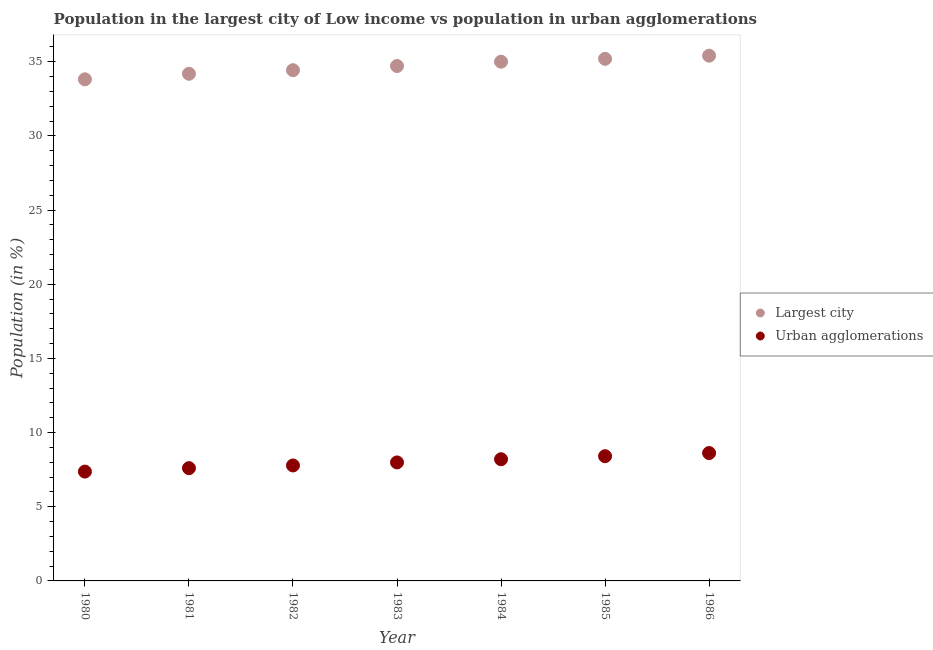How many different coloured dotlines are there?
Offer a terse response. 2. Is the number of dotlines equal to the number of legend labels?
Offer a very short reply. Yes. What is the population in urban agglomerations in 1985?
Ensure brevity in your answer.  8.41. Across all years, what is the maximum population in urban agglomerations?
Keep it short and to the point. 8.62. Across all years, what is the minimum population in urban agglomerations?
Keep it short and to the point. 7.37. In which year was the population in urban agglomerations minimum?
Make the answer very short. 1980. What is the total population in the largest city in the graph?
Ensure brevity in your answer.  242.8. What is the difference between the population in urban agglomerations in 1982 and that in 1985?
Offer a very short reply. -0.62. What is the difference between the population in urban agglomerations in 1982 and the population in the largest city in 1980?
Make the answer very short. -26.04. What is the average population in the largest city per year?
Give a very brief answer. 34.69. In the year 1985, what is the difference between the population in urban agglomerations and population in the largest city?
Your response must be concise. -26.79. What is the ratio of the population in the largest city in 1984 to that in 1986?
Your answer should be compact. 0.99. Is the population in urban agglomerations in 1983 less than that in 1984?
Your answer should be compact. Yes. Is the difference between the population in urban agglomerations in 1982 and 1983 greater than the difference between the population in the largest city in 1982 and 1983?
Make the answer very short. Yes. What is the difference between the highest and the second highest population in urban agglomerations?
Ensure brevity in your answer.  0.21. What is the difference between the highest and the lowest population in the largest city?
Make the answer very short. 1.59. Is the sum of the population in urban agglomerations in 1982 and 1984 greater than the maximum population in the largest city across all years?
Your answer should be very brief. No. Is the population in the largest city strictly less than the population in urban agglomerations over the years?
Your response must be concise. No. What is the difference between two consecutive major ticks on the Y-axis?
Your answer should be very brief. 5. Are the values on the major ticks of Y-axis written in scientific E-notation?
Offer a very short reply. No. Where does the legend appear in the graph?
Provide a short and direct response. Center right. What is the title of the graph?
Keep it short and to the point. Population in the largest city of Low income vs population in urban agglomerations. Does "Register a property" appear as one of the legend labels in the graph?
Make the answer very short. No. What is the label or title of the X-axis?
Offer a terse response. Year. What is the label or title of the Y-axis?
Offer a terse response. Population (in %). What is the Population (in %) in Largest city in 1980?
Offer a terse response. 33.82. What is the Population (in %) of Urban agglomerations in 1980?
Make the answer very short. 7.37. What is the Population (in %) of Largest city in 1981?
Offer a very short reply. 34.2. What is the Population (in %) of Urban agglomerations in 1981?
Your answer should be compact. 7.6. What is the Population (in %) in Largest city in 1982?
Offer a terse response. 34.44. What is the Population (in %) in Urban agglomerations in 1982?
Your answer should be compact. 7.78. What is the Population (in %) in Largest city in 1983?
Make the answer very short. 34.72. What is the Population (in %) of Urban agglomerations in 1983?
Make the answer very short. 7.99. What is the Population (in %) of Largest city in 1984?
Make the answer very short. 35.01. What is the Population (in %) in Urban agglomerations in 1984?
Make the answer very short. 8.2. What is the Population (in %) of Largest city in 1985?
Provide a short and direct response. 35.2. What is the Population (in %) in Urban agglomerations in 1985?
Keep it short and to the point. 8.41. What is the Population (in %) of Largest city in 1986?
Provide a short and direct response. 35.42. What is the Population (in %) of Urban agglomerations in 1986?
Your response must be concise. 8.62. Across all years, what is the maximum Population (in %) in Largest city?
Provide a short and direct response. 35.42. Across all years, what is the maximum Population (in %) in Urban agglomerations?
Your answer should be very brief. 8.62. Across all years, what is the minimum Population (in %) of Largest city?
Offer a terse response. 33.82. Across all years, what is the minimum Population (in %) in Urban agglomerations?
Keep it short and to the point. 7.37. What is the total Population (in %) in Largest city in the graph?
Ensure brevity in your answer.  242.8. What is the total Population (in %) of Urban agglomerations in the graph?
Provide a short and direct response. 55.99. What is the difference between the Population (in %) of Largest city in 1980 and that in 1981?
Give a very brief answer. -0.38. What is the difference between the Population (in %) of Urban agglomerations in 1980 and that in 1981?
Give a very brief answer. -0.23. What is the difference between the Population (in %) in Largest city in 1980 and that in 1982?
Provide a short and direct response. -0.62. What is the difference between the Population (in %) in Urban agglomerations in 1980 and that in 1982?
Your answer should be very brief. -0.41. What is the difference between the Population (in %) of Largest city in 1980 and that in 1983?
Ensure brevity in your answer.  -0.9. What is the difference between the Population (in %) of Urban agglomerations in 1980 and that in 1983?
Keep it short and to the point. -0.62. What is the difference between the Population (in %) of Largest city in 1980 and that in 1984?
Your response must be concise. -1.19. What is the difference between the Population (in %) of Urban agglomerations in 1980 and that in 1984?
Your answer should be very brief. -0.83. What is the difference between the Population (in %) of Largest city in 1980 and that in 1985?
Your answer should be compact. -1.38. What is the difference between the Population (in %) in Urban agglomerations in 1980 and that in 1985?
Provide a succinct answer. -1.04. What is the difference between the Population (in %) of Largest city in 1980 and that in 1986?
Offer a terse response. -1.59. What is the difference between the Population (in %) in Urban agglomerations in 1980 and that in 1986?
Give a very brief answer. -1.25. What is the difference between the Population (in %) in Largest city in 1981 and that in 1982?
Provide a short and direct response. -0.24. What is the difference between the Population (in %) in Urban agglomerations in 1981 and that in 1982?
Ensure brevity in your answer.  -0.18. What is the difference between the Population (in %) in Largest city in 1981 and that in 1983?
Offer a terse response. -0.52. What is the difference between the Population (in %) of Urban agglomerations in 1981 and that in 1983?
Ensure brevity in your answer.  -0.39. What is the difference between the Population (in %) in Largest city in 1981 and that in 1984?
Ensure brevity in your answer.  -0.81. What is the difference between the Population (in %) in Urban agglomerations in 1981 and that in 1984?
Offer a very short reply. -0.6. What is the difference between the Population (in %) in Largest city in 1981 and that in 1985?
Ensure brevity in your answer.  -1.01. What is the difference between the Population (in %) of Urban agglomerations in 1981 and that in 1985?
Provide a succinct answer. -0.81. What is the difference between the Population (in %) in Largest city in 1981 and that in 1986?
Provide a short and direct response. -1.22. What is the difference between the Population (in %) of Urban agglomerations in 1981 and that in 1986?
Provide a succinct answer. -1.02. What is the difference between the Population (in %) of Largest city in 1982 and that in 1983?
Give a very brief answer. -0.28. What is the difference between the Population (in %) of Urban agglomerations in 1982 and that in 1983?
Provide a succinct answer. -0.2. What is the difference between the Population (in %) of Largest city in 1982 and that in 1984?
Provide a succinct answer. -0.57. What is the difference between the Population (in %) of Urban agglomerations in 1982 and that in 1984?
Give a very brief answer. -0.42. What is the difference between the Population (in %) of Largest city in 1982 and that in 1985?
Keep it short and to the point. -0.77. What is the difference between the Population (in %) of Urban agglomerations in 1982 and that in 1985?
Keep it short and to the point. -0.62. What is the difference between the Population (in %) of Largest city in 1982 and that in 1986?
Provide a succinct answer. -0.98. What is the difference between the Population (in %) of Urban agglomerations in 1982 and that in 1986?
Your response must be concise. -0.84. What is the difference between the Population (in %) in Largest city in 1983 and that in 1984?
Your answer should be compact. -0.29. What is the difference between the Population (in %) of Urban agglomerations in 1983 and that in 1984?
Provide a succinct answer. -0.22. What is the difference between the Population (in %) of Largest city in 1983 and that in 1985?
Give a very brief answer. -0.49. What is the difference between the Population (in %) of Urban agglomerations in 1983 and that in 1985?
Provide a succinct answer. -0.42. What is the difference between the Population (in %) in Largest city in 1983 and that in 1986?
Ensure brevity in your answer.  -0.7. What is the difference between the Population (in %) in Urban agglomerations in 1983 and that in 1986?
Keep it short and to the point. -0.63. What is the difference between the Population (in %) of Largest city in 1984 and that in 1985?
Your answer should be very brief. -0.19. What is the difference between the Population (in %) in Urban agglomerations in 1984 and that in 1985?
Ensure brevity in your answer.  -0.2. What is the difference between the Population (in %) of Largest city in 1984 and that in 1986?
Provide a short and direct response. -0.41. What is the difference between the Population (in %) of Urban agglomerations in 1984 and that in 1986?
Your response must be concise. -0.42. What is the difference between the Population (in %) of Largest city in 1985 and that in 1986?
Offer a very short reply. -0.21. What is the difference between the Population (in %) in Urban agglomerations in 1985 and that in 1986?
Keep it short and to the point. -0.21. What is the difference between the Population (in %) of Largest city in 1980 and the Population (in %) of Urban agglomerations in 1981?
Your response must be concise. 26.22. What is the difference between the Population (in %) of Largest city in 1980 and the Population (in %) of Urban agglomerations in 1982?
Your answer should be compact. 26.04. What is the difference between the Population (in %) of Largest city in 1980 and the Population (in %) of Urban agglomerations in 1983?
Offer a very short reply. 25.83. What is the difference between the Population (in %) in Largest city in 1980 and the Population (in %) in Urban agglomerations in 1984?
Provide a succinct answer. 25.62. What is the difference between the Population (in %) of Largest city in 1980 and the Population (in %) of Urban agglomerations in 1985?
Offer a terse response. 25.41. What is the difference between the Population (in %) in Largest city in 1980 and the Population (in %) in Urban agglomerations in 1986?
Offer a terse response. 25.2. What is the difference between the Population (in %) of Largest city in 1981 and the Population (in %) of Urban agglomerations in 1982?
Make the answer very short. 26.41. What is the difference between the Population (in %) in Largest city in 1981 and the Population (in %) in Urban agglomerations in 1983?
Give a very brief answer. 26.21. What is the difference between the Population (in %) of Largest city in 1981 and the Population (in %) of Urban agglomerations in 1984?
Offer a very short reply. 25.99. What is the difference between the Population (in %) in Largest city in 1981 and the Population (in %) in Urban agglomerations in 1985?
Your answer should be compact. 25.79. What is the difference between the Population (in %) of Largest city in 1981 and the Population (in %) of Urban agglomerations in 1986?
Your answer should be very brief. 25.57. What is the difference between the Population (in %) in Largest city in 1982 and the Population (in %) in Urban agglomerations in 1983?
Provide a short and direct response. 26.45. What is the difference between the Population (in %) of Largest city in 1982 and the Population (in %) of Urban agglomerations in 1984?
Offer a very short reply. 26.23. What is the difference between the Population (in %) of Largest city in 1982 and the Population (in %) of Urban agglomerations in 1985?
Give a very brief answer. 26.03. What is the difference between the Population (in %) in Largest city in 1982 and the Population (in %) in Urban agglomerations in 1986?
Give a very brief answer. 25.81. What is the difference between the Population (in %) in Largest city in 1983 and the Population (in %) in Urban agglomerations in 1984?
Your answer should be compact. 26.51. What is the difference between the Population (in %) in Largest city in 1983 and the Population (in %) in Urban agglomerations in 1985?
Keep it short and to the point. 26.31. What is the difference between the Population (in %) of Largest city in 1983 and the Population (in %) of Urban agglomerations in 1986?
Provide a short and direct response. 26.1. What is the difference between the Population (in %) of Largest city in 1984 and the Population (in %) of Urban agglomerations in 1985?
Offer a terse response. 26.6. What is the difference between the Population (in %) in Largest city in 1984 and the Population (in %) in Urban agglomerations in 1986?
Ensure brevity in your answer.  26.39. What is the difference between the Population (in %) of Largest city in 1985 and the Population (in %) of Urban agglomerations in 1986?
Your answer should be compact. 26.58. What is the average Population (in %) in Largest city per year?
Your answer should be very brief. 34.69. What is the average Population (in %) of Urban agglomerations per year?
Ensure brevity in your answer.  8. In the year 1980, what is the difference between the Population (in %) in Largest city and Population (in %) in Urban agglomerations?
Provide a succinct answer. 26.45. In the year 1981, what is the difference between the Population (in %) of Largest city and Population (in %) of Urban agglomerations?
Keep it short and to the point. 26.59. In the year 1982, what is the difference between the Population (in %) of Largest city and Population (in %) of Urban agglomerations?
Your answer should be compact. 26.65. In the year 1983, what is the difference between the Population (in %) in Largest city and Population (in %) in Urban agglomerations?
Keep it short and to the point. 26.73. In the year 1984, what is the difference between the Population (in %) of Largest city and Population (in %) of Urban agglomerations?
Your response must be concise. 26.8. In the year 1985, what is the difference between the Population (in %) in Largest city and Population (in %) in Urban agglomerations?
Your response must be concise. 26.79. In the year 1986, what is the difference between the Population (in %) of Largest city and Population (in %) of Urban agglomerations?
Provide a short and direct response. 26.79. What is the ratio of the Population (in %) of Largest city in 1980 to that in 1981?
Offer a very short reply. 0.99. What is the ratio of the Population (in %) of Urban agglomerations in 1980 to that in 1981?
Your answer should be compact. 0.97. What is the ratio of the Population (in %) of Largest city in 1980 to that in 1982?
Your response must be concise. 0.98. What is the ratio of the Population (in %) of Urban agglomerations in 1980 to that in 1982?
Offer a terse response. 0.95. What is the ratio of the Population (in %) of Largest city in 1980 to that in 1983?
Your answer should be very brief. 0.97. What is the ratio of the Population (in %) of Urban agglomerations in 1980 to that in 1983?
Make the answer very short. 0.92. What is the ratio of the Population (in %) of Urban agglomerations in 1980 to that in 1984?
Keep it short and to the point. 0.9. What is the ratio of the Population (in %) in Largest city in 1980 to that in 1985?
Make the answer very short. 0.96. What is the ratio of the Population (in %) of Urban agglomerations in 1980 to that in 1985?
Your answer should be very brief. 0.88. What is the ratio of the Population (in %) of Largest city in 1980 to that in 1986?
Make the answer very short. 0.95. What is the ratio of the Population (in %) in Urban agglomerations in 1980 to that in 1986?
Offer a very short reply. 0.85. What is the ratio of the Population (in %) of Largest city in 1981 to that in 1982?
Your response must be concise. 0.99. What is the ratio of the Population (in %) in Urban agglomerations in 1981 to that in 1982?
Your answer should be very brief. 0.98. What is the ratio of the Population (in %) in Largest city in 1981 to that in 1983?
Offer a terse response. 0.98. What is the ratio of the Population (in %) in Urban agglomerations in 1981 to that in 1983?
Give a very brief answer. 0.95. What is the ratio of the Population (in %) in Largest city in 1981 to that in 1984?
Keep it short and to the point. 0.98. What is the ratio of the Population (in %) of Urban agglomerations in 1981 to that in 1984?
Your answer should be very brief. 0.93. What is the ratio of the Population (in %) of Largest city in 1981 to that in 1985?
Your response must be concise. 0.97. What is the ratio of the Population (in %) of Urban agglomerations in 1981 to that in 1985?
Keep it short and to the point. 0.9. What is the ratio of the Population (in %) of Largest city in 1981 to that in 1986?
Your answer should be compact. 0.97. What is the ratio of the Population (in %) in Urban agglomerations in 1981 to that in 1986?
Make the answer very short. 0.88. What is the ratio of the Population (in %) in Largest city in 1982 to that in 1983?
Give a very brief answer. 0.99. What is the ratio of the Population (in %) of Urban agglomerations in 1982 to that in 1983?
Offer a terse response. 0.97. What is the ratio of the Population (in %) of Largest city in 1982 to that in 1984?
Provide a succinct answer. 0.98. What is the ratio of the Population (in %) in Urban agglomerations in 1982 to that in 1984?
Keep it short and to the point. 0.95. What is the ratio of the Population (in %) in Largest city in 1982 to that in 1985?
Make the answer very short. 0.98. What is the ratio of the Population (in %) in Urban agglomerations in 1982 to that in 1985?
Provide a short and direct response. 0.93. What is the ratio of the Population (in %) of Largest city in 1982 to that in 1986?
Your answer should be very brief. 0.97. What is the ratio of the Population (in %) in Urban agglomerations in 1982 to that in 1986?
Your answer should be very brief. 0.9. What is the ratio of the Population (in %) in Largest city in 1983 to that in 1984?
Give a very brief answer. 0.99. What is the ratio of the Population (in %) in Urban agglomerations in 1983 to that in 1984?
Your answer should be very brief. 0.97. What is the ratio of the Population (in %) in Largest city in 1983 to that in 1985?
Make the answer very short. 0.99. What is the ratio of the Population (in %) in Largest city in 1983 to that in 1986?
Offer a terse response. 0.98. What is the ratio of the Population (in %) of Urban agglomerations in 1983 to that in 1986?
Offer a very short reply. 0.93. What is the ratio of the Population (in %) of Urban agglomerations in 1984 to that in 1985?
Offer a very short reply. 0.98. What is the ratio of the Population (in %) of Urban agglomerations in 1984 to that in 1986?
Ensure brevity in your answer.  0.95. What is the ratio of the Population (in %) of Largest city in 1985 to that in 1986?
Keep it short and to the point. 0.99. What is the ratio of the Population (in %) in Urban agglomerations in 1985 to that in 1986?
Offer a very short reply. 0.98. What is the difference between the highest and the second highest Population (in %) of Largest city?
Your response must be concise. 0.21. What is the difference between the highest and the second highest Population (in %) in Urban agglomerations?
Provide a succinct answer. 0.21. What is the difference between the highest and the lowest Population (in %) of Largest city?
Offer a terse response. 1.59. 